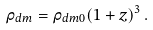<formula> <loc_0><loc_0><loc_500><loc_500>\rho _ { d m } = \rho _ { d m 0 } ( 1 + z ) ^ { 3 } \, .</formula> 